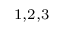Convert formula to latex. <formula><loc_0><loc_0><loc_500><loc_500>^ { 1 , 2 , 3 }</formula> 